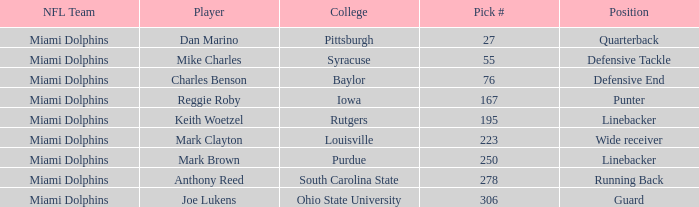Which Position has a Pick # lower than 278 for Player Charles Benson? Defensive End. Can you parse all the data within this table? {'header': ['NFL Team', 'Player', 'College', 'Pick #', 'Position'], 'rows': [['Miami Dolphins', 'Dan Marino', 'Pittsburgh', '27', 'Quarterback'], ['Miami Dolphins', 'Mike Charles', 'Syracuse', '55', 'Defensive Tackle'], ['Miami Dolphins', 'Charles Benson', 'Baylor', '76', 'Defensive End'], ['Miami Dolphins', 'Reggie Roby', 'Iowa', '167', 'Punter'], ['Miami Dolphins', 'Keith Woetzel', 'Rutgers', '195', 'Linebacker'], ['Miami Dolphins', 'Mark Clayton', 'Louisville', '223', 'Wide receiver'], ['Miami Dolphins', 'Mark Brown', 'Purdue', '250', 'Linebacker'], ['Miami Dolphins', 'Anthony Reed', 'South Carolina State', '278', 'Running Back'], ['Miami Dolphins', 'Joe Lukens', 'Ohio State University', '306', 'Guard']]} 